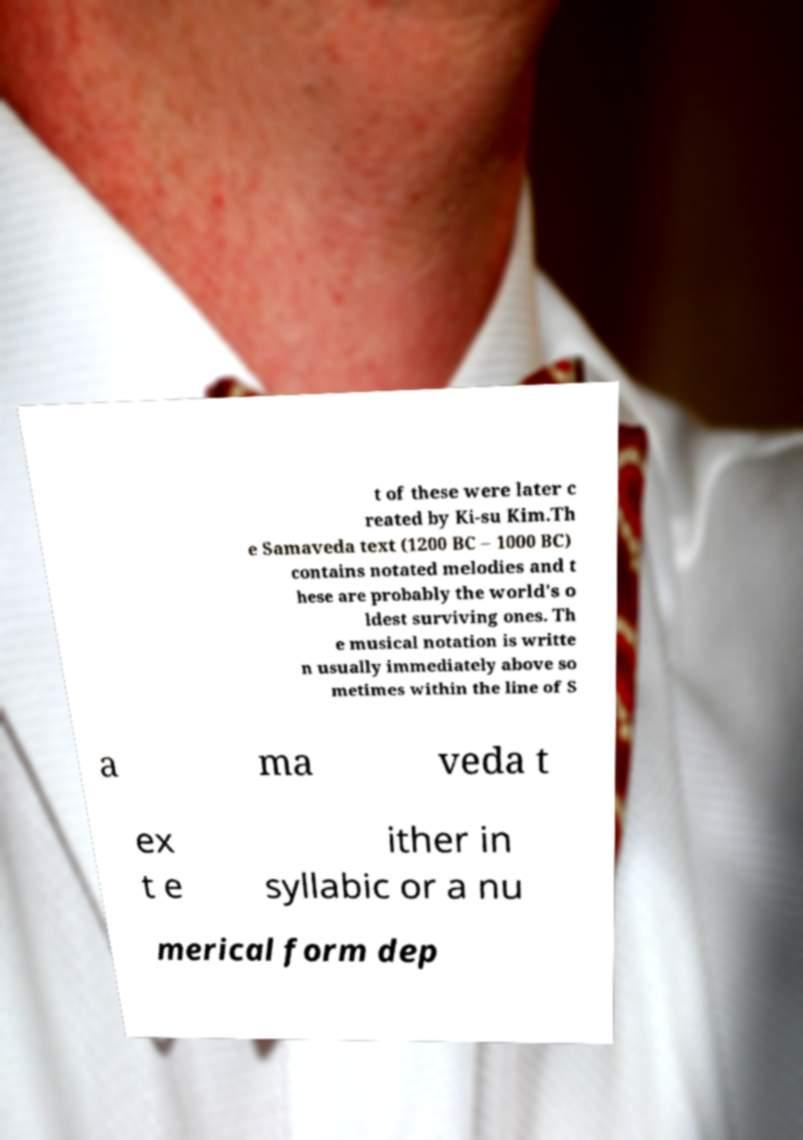Can you read and provide the text displayed in the image?This photo seems to have some interesting text. Can you extract and type it out for me? t of these were later c reated by Ki-su Kim.Th e Samaveda text (1200 BC – 1000 BC) contains notated melodies and t hese are probably the world's o ldest surviving ones. Th e musical notation is writte n usually immediately above so metimes within the line of S a ma veda t ex t e ither in syllabic or a nu merical form dep 